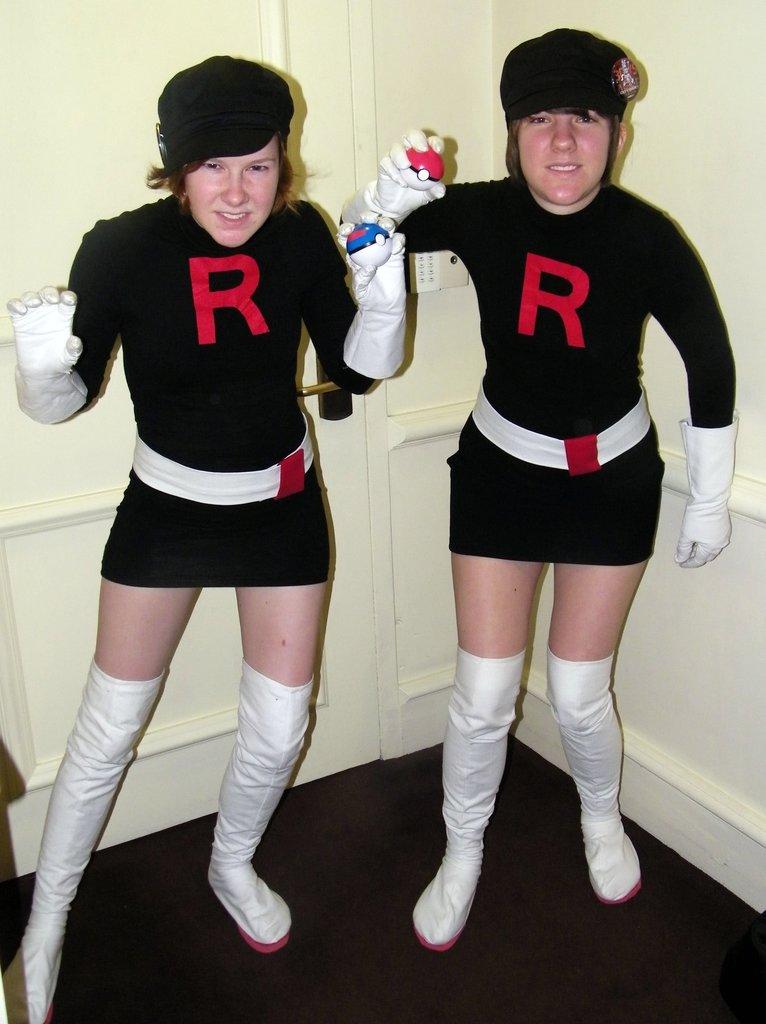What letter is on both outfits?
Your answer should be very brief. R. Are they wearing the same outfits?
Make the answer very short. Answering does not require reading text in the image. 